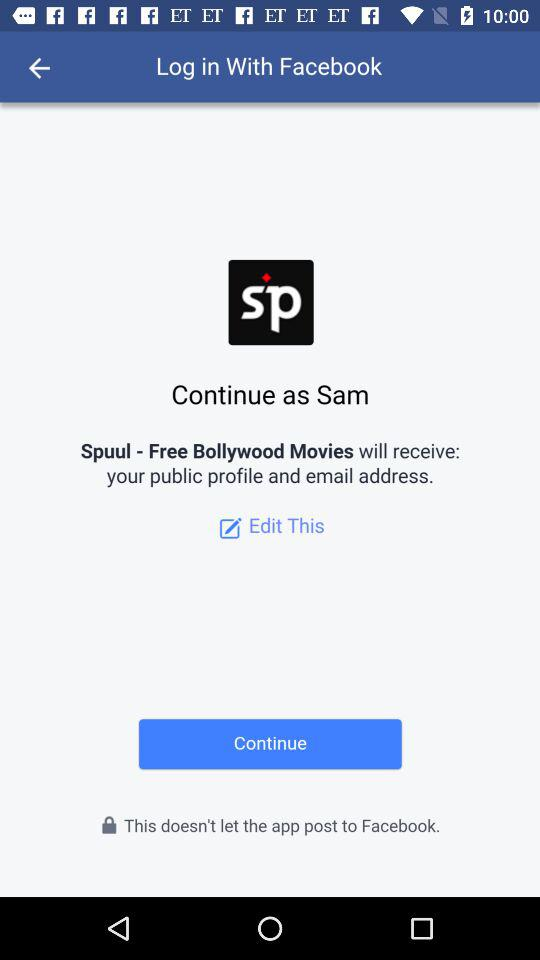What is the user name? The user name is Sam. 